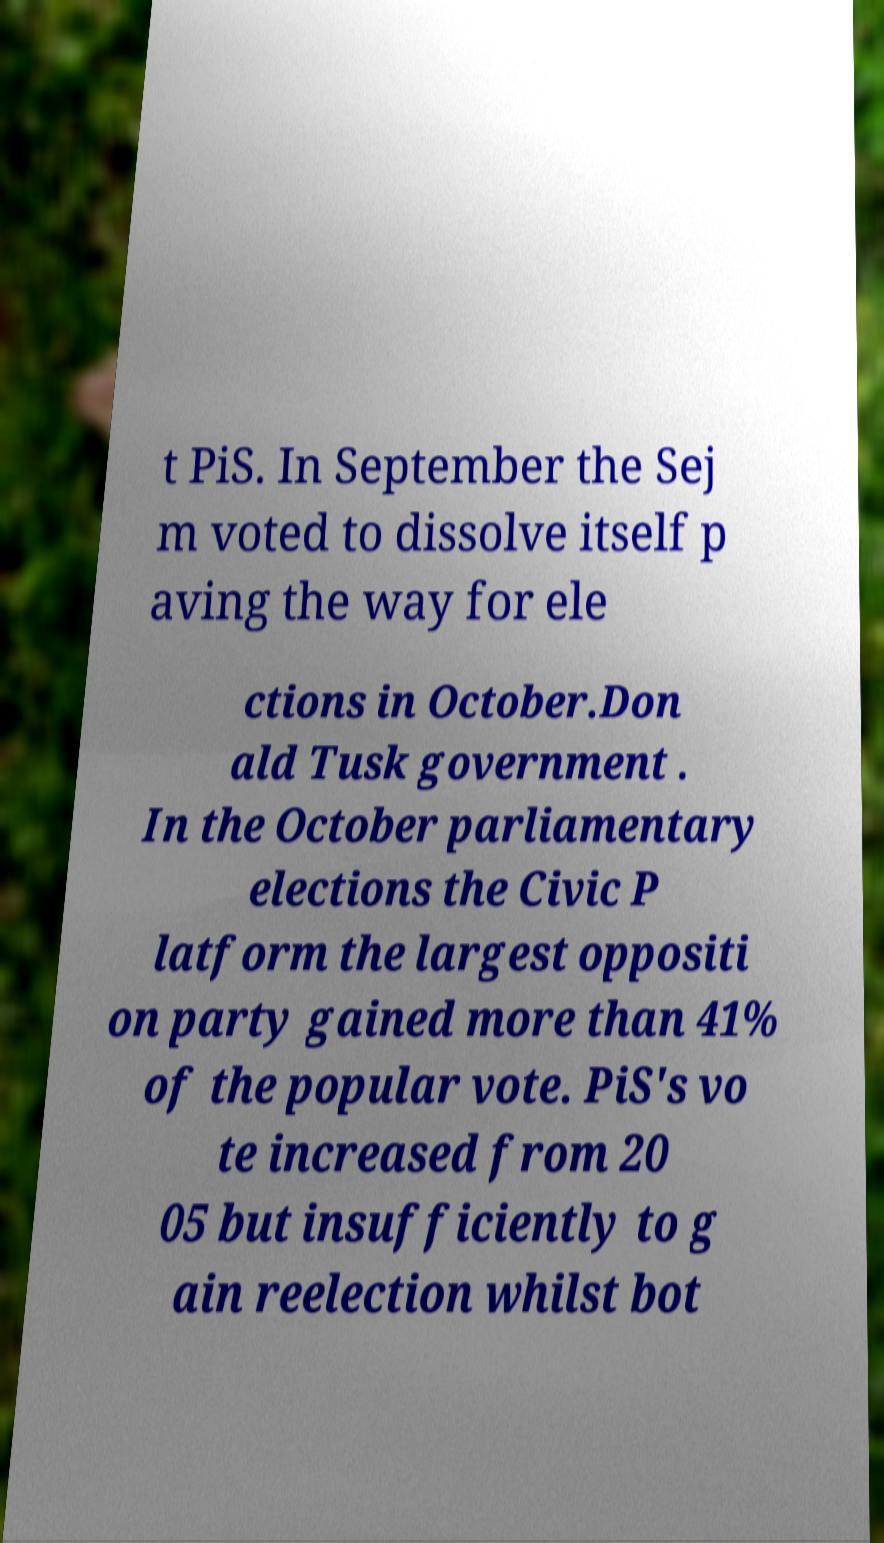Can you accurately transcribe the text from the provided image for me? t PiS. In September the Sej m voted to dissolve itself p aving the way for ele ctions in October.Don ald Tusk government . In the October parliamentary elections the Civic P latform the largest oppositi on party gained more than 41% of the popular vote. PiS's vo te increased from 20 05 but insufficiently to g ain reelection whilst bot 